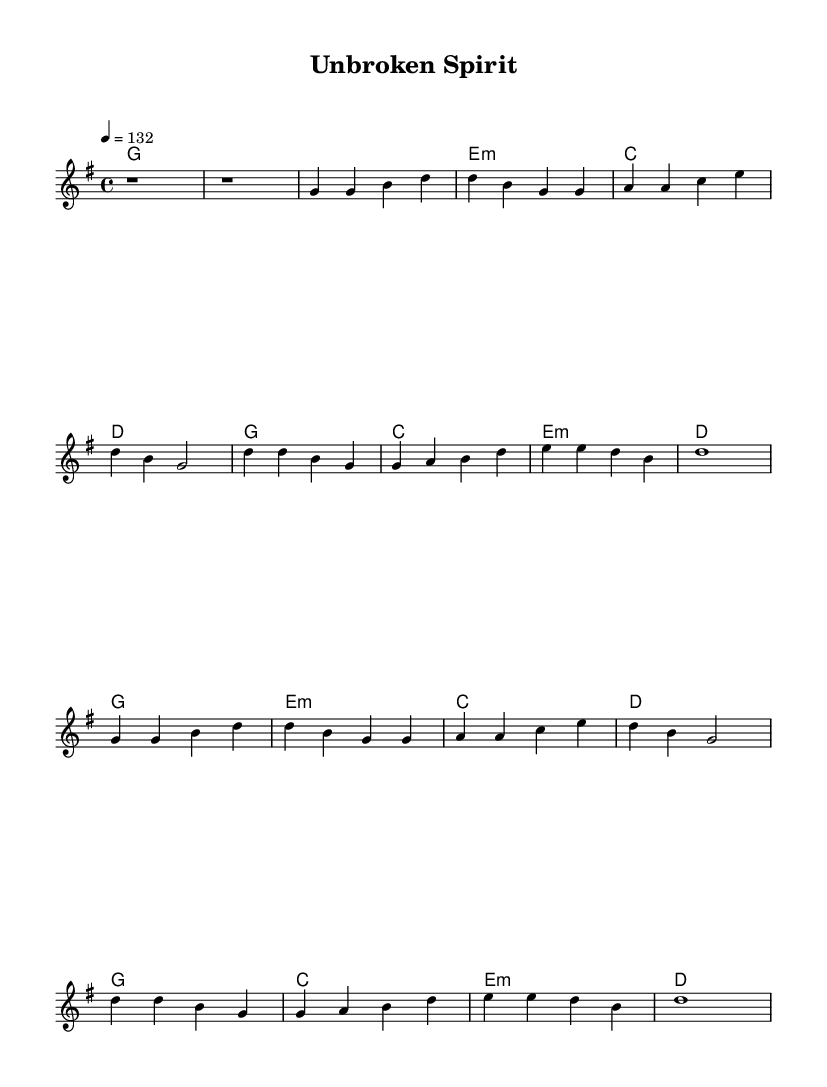What is the key signature of this music? The key signature is G major, which has one sharp (F#). This can be identified by looking at the key signature indicated at the beginning of the staff.
Answer: G major What is the time signature of this music? The time signature is 4/4, which means there are four beats in each measure. This is denoted at the beginning of the sheet music, directly following the key signature.
Answer: 4/4 What is the tempo of this piece? The tempo is set at 132 beats per minute. This is indicated in the tempo marking, placed at the beginning of the score, which instructs the performer on how fast to play.
Answer: 132 How many measures are in the chorus section? The chorus section consists of four measures. By counting the measures indicated within the chorus, we can see it repeats four times based on the layout and structure.
Answer: 4 What chord precedes the first chorus? The chord that precedes the first chorus is G major. To determine this, look at the last chord in the verse right before the chorus section begins.
Answer: G Which chord is used in the second measure of the verse? The chord used in the second measure of the verse is E minor. This is identified by locating the chord names that align with the melody in the verse section.
Answer: E minor What element in the music represents the theme of resilience? The energetic melody and driving rhythms illustrate resilience. Analyzing the lively tempo, repetitive patterns, and strong, uplifting chords reflects an uplifting theme of strength and adaptability commonly associated with stories of indigenous peoples.
Answer: Energetic melody 